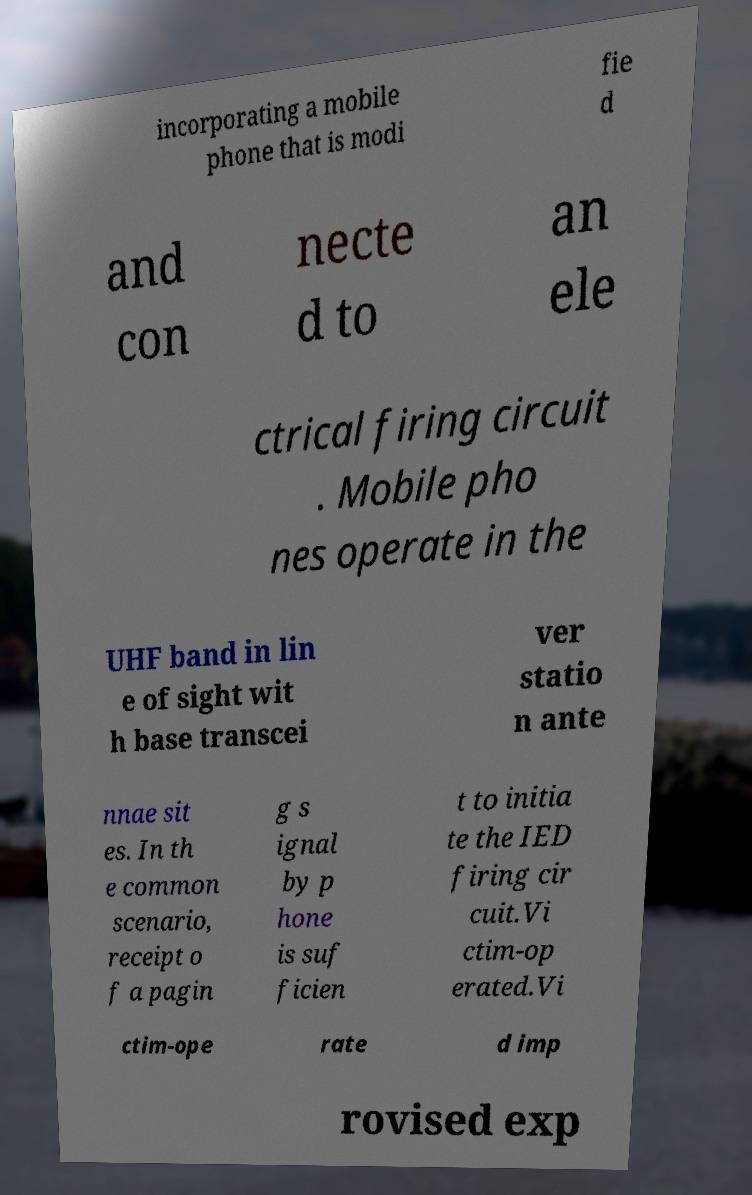Can you read and provide the text displayed in the image?This photo seems to have some interesting text. Can you extract and type it out for me? incorporating a mobile phone that is modi fie d and con necte d to an ele ctrical firing circuit . Mobile pho nes operate in the UHF band in lin e of sight wit h base transcei ver statio n ante nnae sit es. In th e common scenario, receipt o f a pagin g s ignal by p hone is suf ficien t to initia te the IED firing cir cuit.Vi ctim-op erated.Vi ctim-ope rate d imp rovised exp 